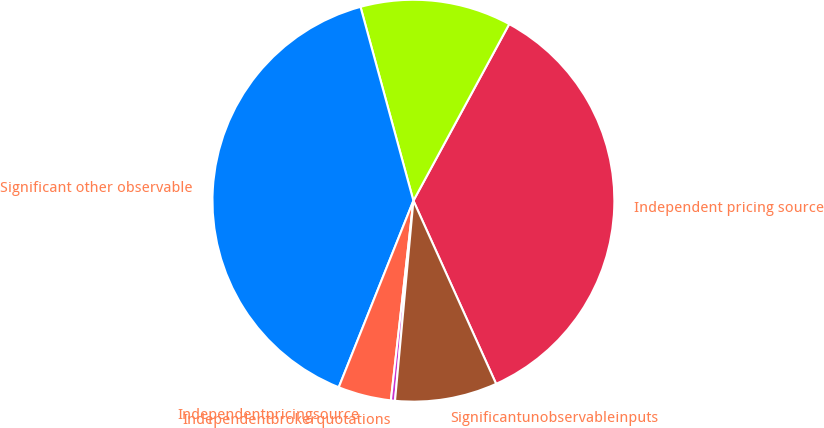Convert chart. <chart><loc_0><loc_0><loc_500><loc_500><pie_chart><fcel>Independent pricing source<fcel>Unnamed: 1<fcel>Significant other observable<fcel>Independentpricingsource<fcel>Independentbrokerquotations<fcel>Significantunobservableinputs<nl><fcel>35.34%<fcel>12.15%<fcel>39.7%<fcel>4.27%<fcel>0.33%<fcel>8.21%<nl></chart> 